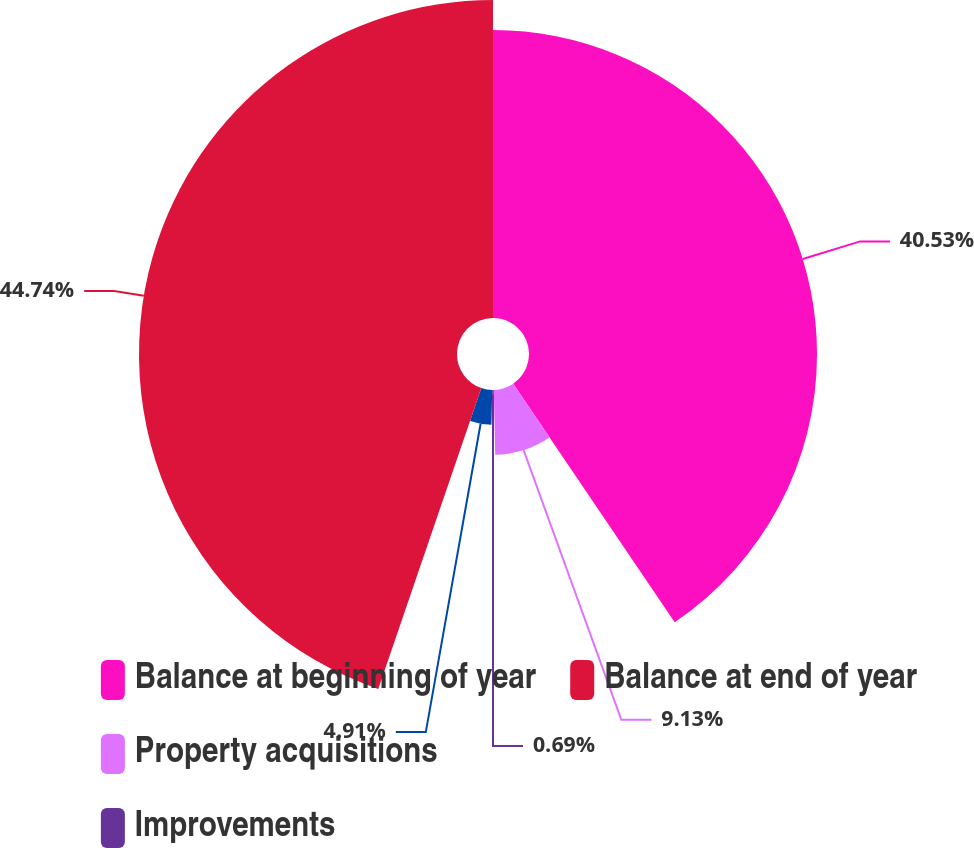Convert chart to OTSL. <chart><loc_0><loc_0><loc_500><loc_500><pie_chart><fcel>Balance at beginning of year<fcel>Property acquisitions<fcel>Improvements<fcel>Unnamed: 3<fcel>Balance at end of year<nl><fcel>40.53%<fcel>9.13%<fcel>0.69%<fcel>4.91%<fcel>44.75%<nl></chart> 